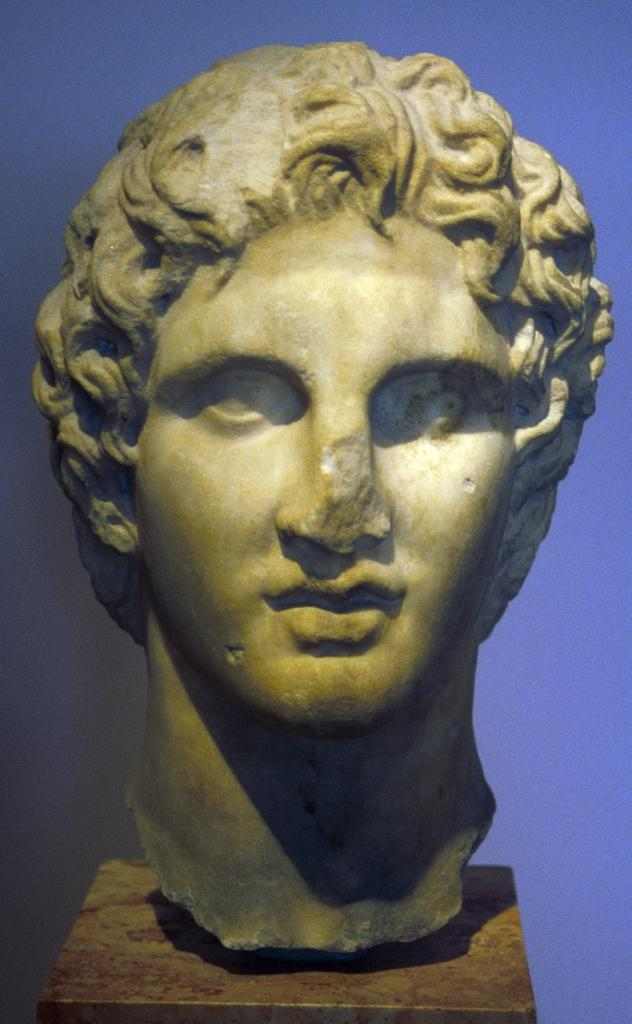What is the main subject in the foreground of the image? There is a person's statue on the table in the foreground. What can be seen in the background of the image? There is a wall in the background. Can you describe the setting where the image might have been taken? The image may have been taken in a hall, based on the presence of a table and a wall. How much profit did the chalk make in the image? There is no chalk present in the image, so it is not possible to determine any profit made. 